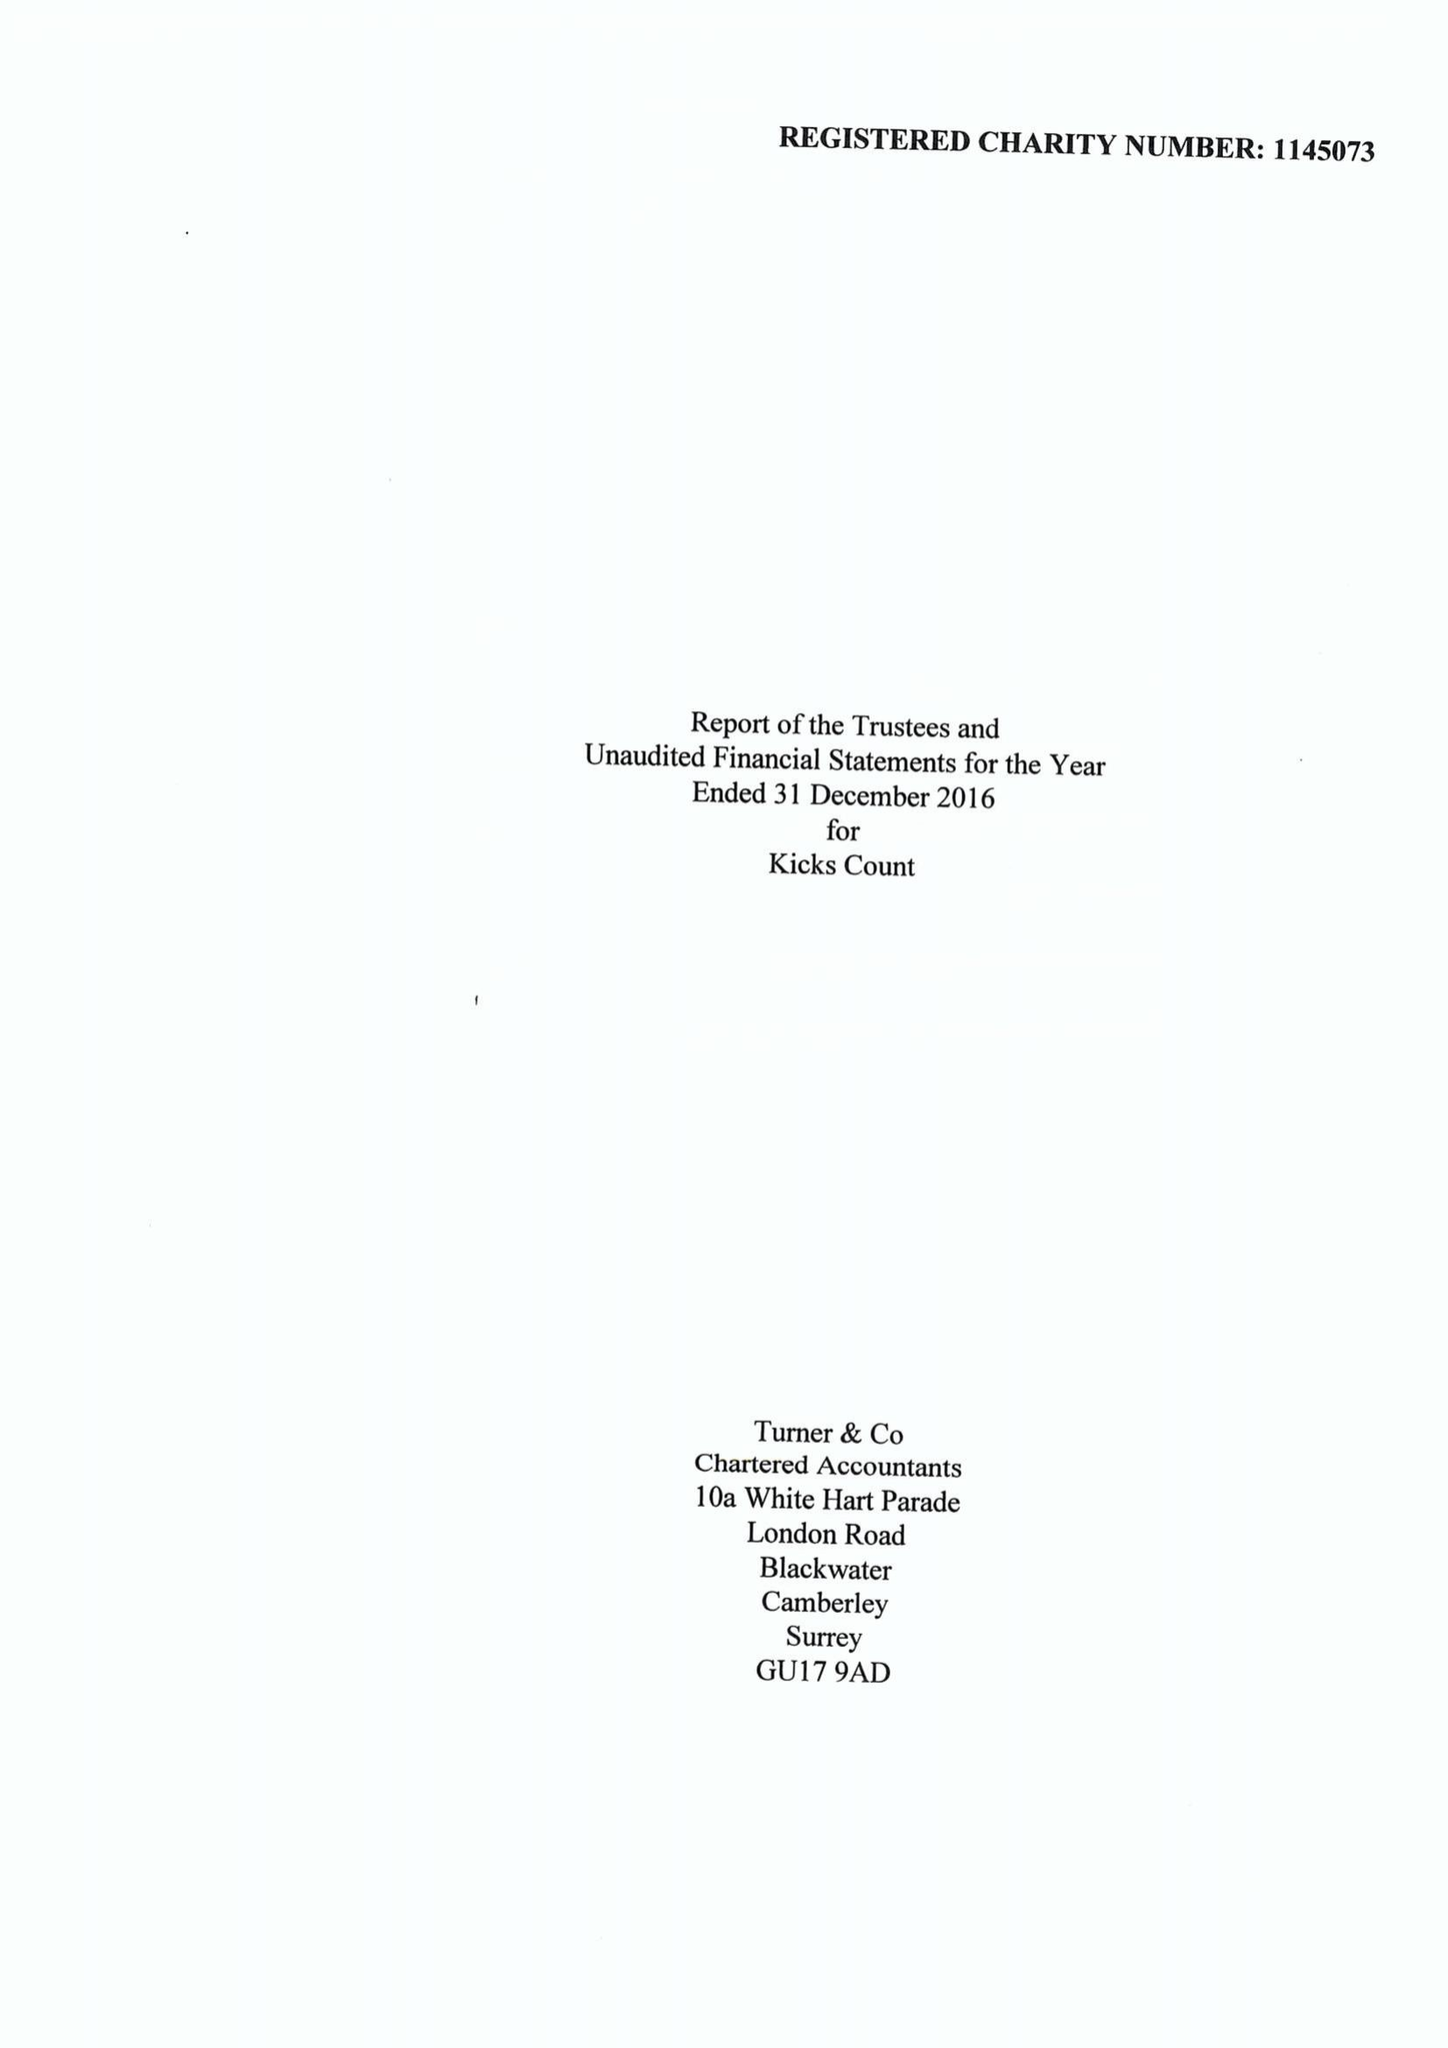What is the value for the address__street_line?
Answer the question using a single word or phrase. 10 THE COPSE 